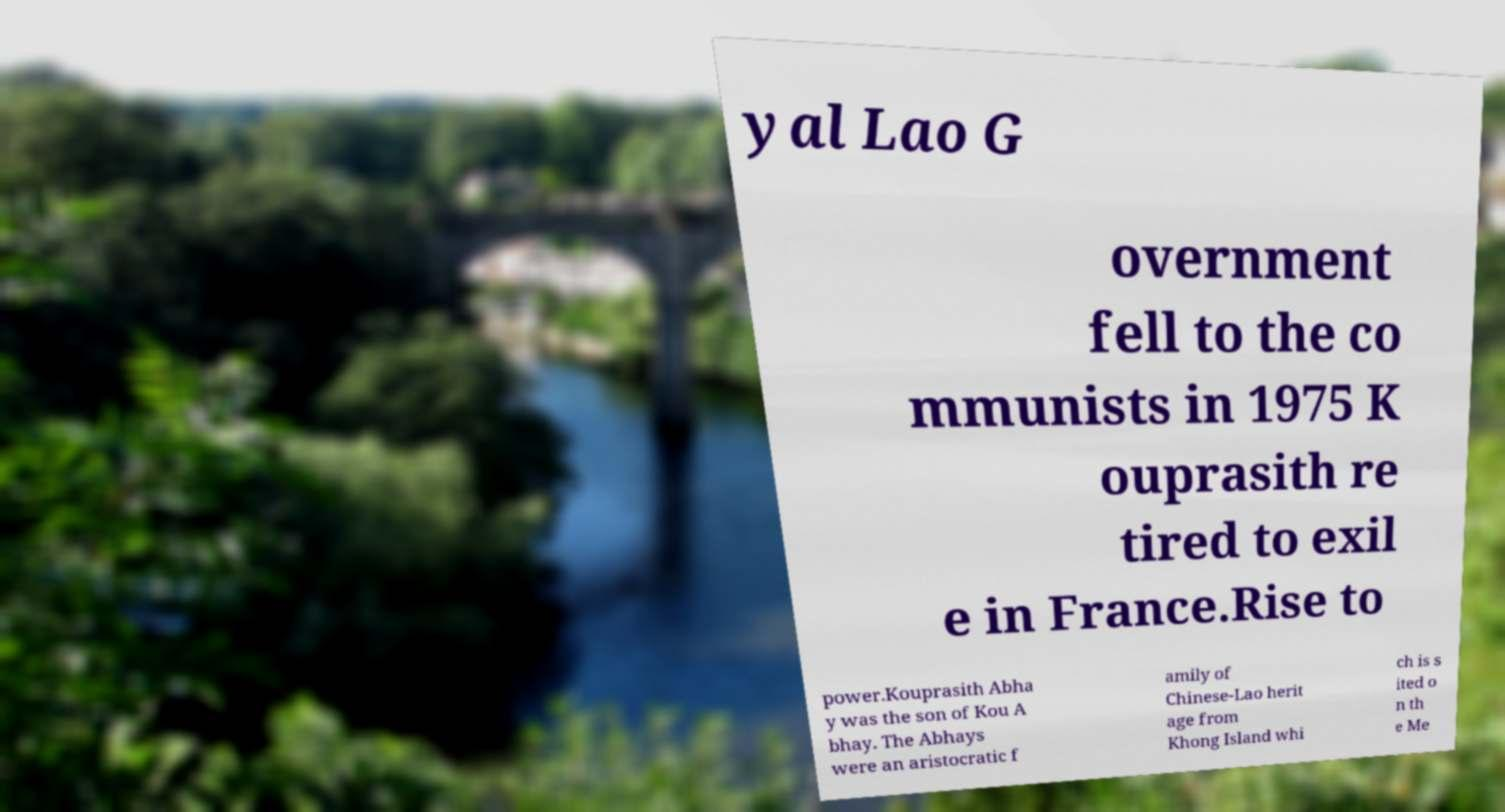There's text embedded in this image that I need extracted. Can you transcribe it verbatim? yal Lao G overnment fell to the co mmunists in 1975 K ouprasith re tired to exil e in France.Rise to power.Kouprasith Abha y was the son of Kou A bhay. The Abhays were an aristocratic f amily of Chinese-Lao herit age from Khong Island whi ch is s ited o n th e Me 